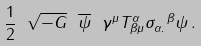Convert formula to latex. <formula><loc_0><loc_0><loc_500><loc_500>\frac { 1 } { 2 } \ \sqrt { - G } \ \overline { \psi } \ \gamma ^ { \mu } T ^ { \alpha } _ { \beta \mu } \sigma _ { \alpha . } ^ { \ \beta } \psi \, .</formula> 